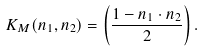Convert formula to latex. <formula><loc_0><loc_0><loc_500><loc_500>K _ { M } ( { n } _ { 1 } , { n } _ { 2 } ) = \left ( \frac { 1 - { n } _ { 1 } \cdot { n } _ { 2 } } { 2 } \right ) .</formula> 